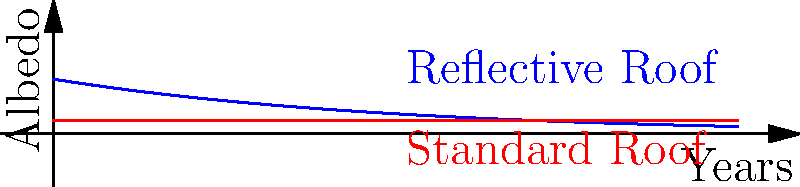A roofing project involves installing a reflective coating on a 500 m² commercial roof. The initial albedo of the reflective coating is 0.8, which decreases exponentially over time according to the function $A(t) = 0.8e^{-t/5}$, where $t$ is the time in years. A standard roof has a constant albedo of 0.2. The average solar radiation in the area is 200 W/m². How much more energy (in kWh) is reflected by the coated roof compared to a standard roof over a 10-year period? To solve this problem, we need to follow these steps:

1) The difference in energy reflected is proportional to the difference in albedo between the two roofs.

2) For the reflective roof, we need to integrate the albedo function over 10 years:
   $$\int_0^{10} 0.8e^{-t/5} dt$$

3) For the standard roof, the albedo is constant at 0.2, so over 10 years it's simply:
   $$10 * 0.2 = 2$$

4) Solving the integral for the reflective roof:
   $$\int_0^{10} 0.8e^{-t/5} dt = -4(e^{-10/5} - 1) \approx 3.35$$

5) The difference in total albedo over 10 years is:
   $$3.35 - 2 = 1.35$$

6) This difference in albedo means 1.35 * 200 W/m² = 270 W/m² more energy reflected on average.

7) For the total 500 m² roof over 10 years (87,600 hours):
   $$270 * 500 * 87600 = 11,826,000,000 Wh = 11,826,000 kWh$$

Therefore, the reflective roof reflects 11,826,000 kWh more energy over 10 years.
Answer: 11,826,000 kWh 